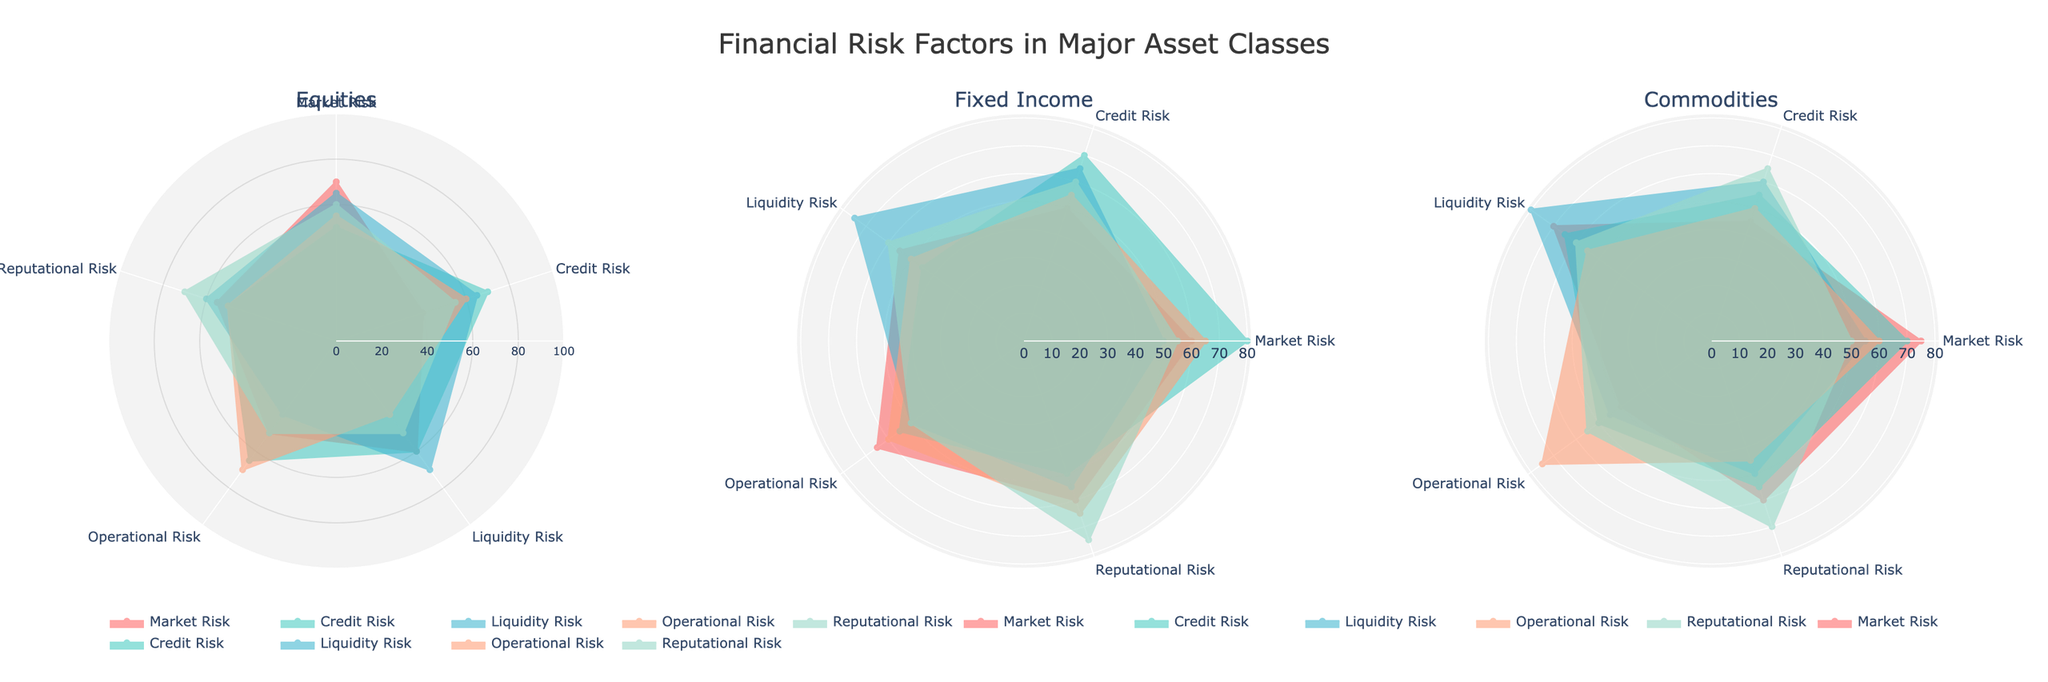Which asset class has the highest market risk value? To determine this, locate the highest market risk value across all three asset class subplots: Equities, Fixed Income, and Commodities. The highest value for market risk appears in the Commodities subplot.
Answer: Commodities Which category has the lowest liquidity risk value in Equities? For the Equities subplot, compare the liquidity risk values among all categories - Market Risk, Credit Risk, Liquidity Risk, Operational Risk, and Reputational Risk. The lowest value is for Operational Risk.
Answer: Operational Risk Compare the credit risk values of Fixed Income and Commodities. Which one is higher? Locate the credit risk values on both Fixed Income and Commodities subplots. Fixed Income has a higher credit risk value at 80 compared to Commodities, which is 70.
Answer: Fixed Income What’s the average reputational risk value for the Fixed Income asset class? To compute the average, sum up the reputational risk values enumerated in the Fixed Income section (60, 50, 55, 65, 75), and then divide by the number of categories (5). Average = (60 + 50 + 55 + 65 + 75) / 5 = 61.
Answer: 61 Which asset class has more variability in operational risk? Compare the range of operational risk values for each asset class. Check from highest to lowest for each subplot. Fixed Income ranges from 50-65, Equities from 40-70, and Commodities from 45-75. Commodities show the most variability.
Answer: Commodities Which risk category seems most balanced across all asset classes? Examine the consistency of values among all asset classes for each risk category (Market, Credit, Liquidity, Operational, Reputational). Each category's variation should be minimized. Reputational Risk values appear most balanced with relatively small variation.
Answer: Reputational Compare the liquidity risk value in Equities with its market risk value. Is it higher or lower? Observe the Liquidity Risk and Market Risk values for Equities. Liquidity Risk in Equities is 70, and Market Risk is 70, indicating they are equal.
Answer: Equal For Fixed Income, which risk category has the highest value? Identify the highest value within the Fixed Income subplot by comparing all risk categories. Credit Risk is the highest with a value of 80.
Answer: Credit Risk Which asset class has the lowest operational risk value? Compare the minimum operational risk values across Equities, Fixed Income, and Commodities subplots. Equities show the lowest operational risk value at 40.
Answer: Equities 